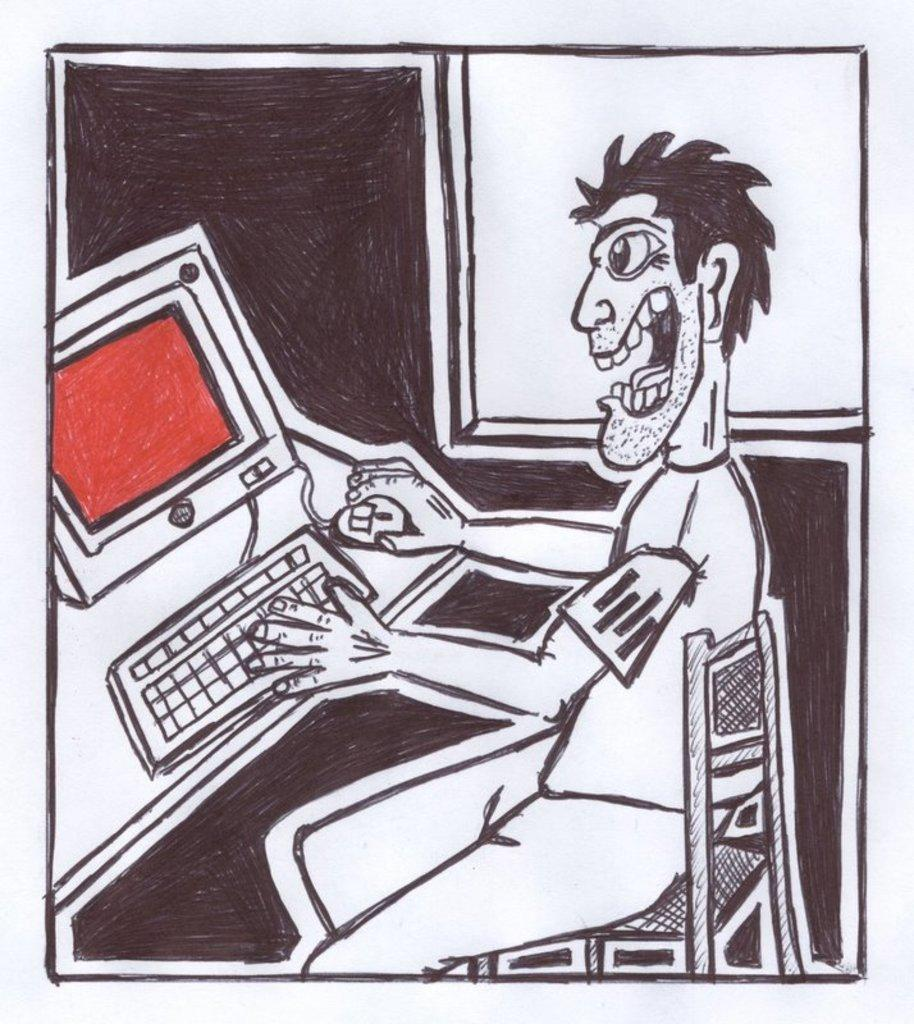What is shown on the paper in the image? There is a drawing on the paper. What is the subject of the drawing? The drawing depicts a person sitting on a chair. Are there any additional elements in the drawing? Yes, the drawing also includes a system. What type of coil is used in the drawing to represent the person's hair? There is no coil present in the drawing to represent the person's hair; the drawing simply depicts a person sitting on a chair. How many calculators are visible in the drawing? There are no calculators visible in the drawing; the drawing only includes a person sitting on a chair and a system. 